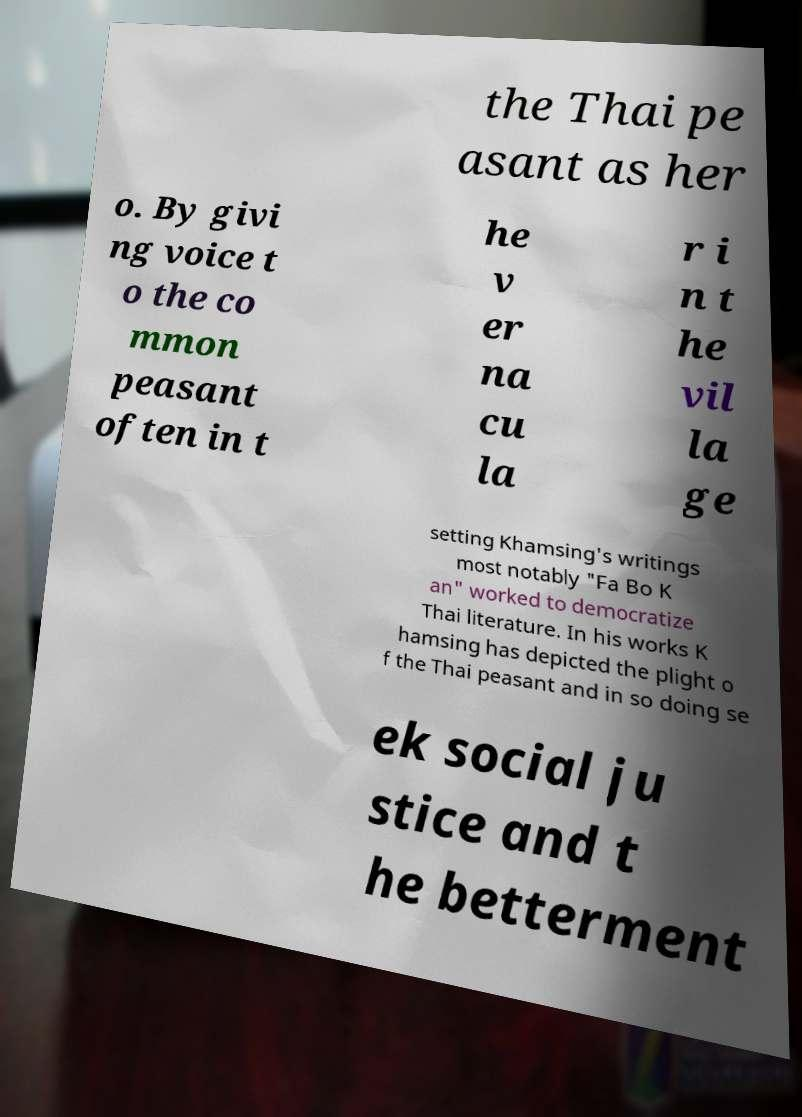I need the written content from this picture converted into text. Can you do that? the Thai pe asant as her o. By givi ng voice t o the co mmon peasant often in t he v er na cu la r i n t he vil la ge setting Khamsing's writings most notably "Fa Bo K an" worked to democratize Thai literature. In his works K hamsing has depicted the plight o f the Thai peasant and in so doing se ek social ju stice and t he betterment 